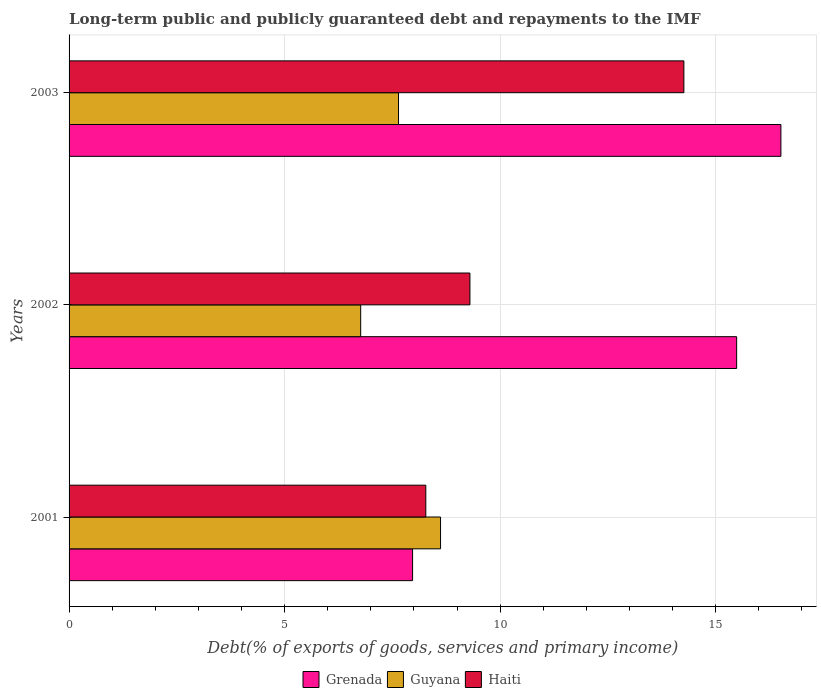How many bars are there on the 1st tick from the top?
Your answer should be compact. 3. How many bars are there on the 1st tick from the bottom?
Give a very brief answer. 3. In how many cases, is the number of bars for a given year not equal to the number of legend labels?
Provide a short and direct response. 0. What is the debt and repayments in Haiti in 2001?
Offer a very short reply. 8.28. Across all years, what is the maximum debt and repayments in Grenada?
Your answer should be very brief. 16.51. Across all years, what is the minimum debt and repayments in Guyana?
Give a very brief answer. 6.76. In which year was the debt and repayments in Grenada maximum?
Make the answer very short. 2003. In which year was the debt and repayments in Grenada minimum?
Offer a terse response. 2001. What is the total debt and repayments in Guyana in the graph?
Keep it short and to the point. 23.02. What is the difference between the debt and repayments in Haiti in 2001 and that in 2002?
Provide a short and direct response. -1.02. What is the difference between the debt and repayments in Grenada in 2003 and the debt and repayments in Haiti in 2002?
Keep it short and to the point. 7.21. What is the average debt and repayments in Haiti per year?
Keep it short and to the point. 10.61. In the year 2002, what is the difference between the debt and repayments in Grenada and debt and repayments in Guyana?
Offer a very short reply. 8.72. In how many years, is the debt and repayments in Haiti greater than 5 %?
Keep it short and to the point. 3. What is the ratio of the debt and repayments in Haiti in 2001 to that in 2003?
Your answer should be very brief. 0.58. Is the difference between the debt and repayments in Grenada in 2002 and 2003 greater than the difference between the debt and repayments in Guyana in 2002 and 2003?
Ensure brevity in your answer.  No. What is the difference between the highest and the second highest debt and repayments in Guyana?
Your answer should be very brief. 0.98. What is the difference between the highest and the lowest debt and repayments in Haiti?
Keep it short and to the point. 5.99. What does the 2nd bar from the top in 2003 represents?
Your answer should be compact. Guyana. What does the 1st bar from the bottom in 2003 represents?
Keep it short and to the point. Grenada. Is it the case that in every year, the sum of the debt and repayments in Haiti and debt and repayments in Guyana is greater than the debt and repayments in Grenada?
Make the answer very short. Yes. How many bars are there?
Offer a terse response. 9. What is the difference between two consecutive major ticks on the X-axis?
Provide a short and direct response. 5. Are the values on the major ticks of X-axis written in scientific E-notation?
Make the answer very short. No. Does the graph contain any zero values?
Your answer should be very brief. No. How many legend labels are there?
Keep it short and to the point. 3. What is the title of the graph?
Keep it short and to the point. Long-term public and publicly guaranteed debt and repayments to the IMF. Does "Niger" appear as one of the legend labels in the graph?
Your answer should be very brief. No. What is the label or title of the X-axis?
Your answer should be compact. Debt(% of exports of goods, services and primary income). What is the label or title of the Y-axis?
Make the answer very short. Years. What is the Debt(% of exports of goods, services and primary income) in Grenada in 2001?
Keep it short and to the point. 7.97. What is the Debt(% of exports of goods, services and primary income) in Guyana in 2001?
Keep it short and to the point. 8.62. What is the Debt(% of exports of goods, services and primary income) of Haiti in 2001?
Offer a terse response. 8.28. What is the Debt(% of exports of goods, services and primary income) of Grenada in 2002?
Ensure brevity in your answer.  15.49. What is the Debt(% of exports of goods, services and primary income) of Guyana in 2002?
Ensure brevity in your answer.  6.76. What is the Debt(% of exports of goods, services and primary income) of Haiti in 2002?
Keep it short and to the point. 9.3. What is the Debt(% of exports of goods, services and primary income) of Grenada in 2003?
Your answer should be very brief. 16.51. What is the Debt(% of exports of goods, services and primary income) in Guyana in 2003?
Provide a short and direct response. 7.64. What is the Debt(% of exports of goods, services and primary income) in Haiti in 2003?
Your answer should be compact. 14.26. Across all years, what is the maximum Debt(% of exports of goods, services and primary income) in Grenada?
Provide a short and direct response. 16.51. Across all years, what is the maximum Debt(% of exports of goods, services and primary income) of Guyana?
Provide a succinct answer. 8.62. Across all years, what is the maximum Debt(% of exports of goods, services and primary income) in Haiti?
Your answer should be very brief. 14.26. Across all years, what is the minimum Debt(% of exports of goods, services and primary income) of Grenada?
Provide a short and direct response. 7.97. Across all years, what is the minimum Debt(% of exports of goods, services and primary income) of Guyana?
Provide a succinct answer. 6.76. Across all years, what is the minimum Debt(% of exports of goods, services and primary income) in Haiti?
Your response must be concise. 8.28. What is the total Debt(% of exports of goods, services and primary income) in Grenada in the graph?
Your response must be concise. 39.96. What is the total Debt(% of exports of goods, services and primary income) in Guyana in the graph?
Give a very brief answer. 23.02. What is the total Debt(% of exports of goods, services and primary income) of Haiti in the graph?
Your answer should be very brief. 31.83. What is the difference between the Debt(% of exports of goods, services and primary income) in Grenada in 2001 and that in 2002?
Provide a succinct answer. -7.52. What is the difference between the Debt(% of exports of goods, services and primary income) of Guyana in 2001 and that in 2002?
Offer a terse response. 1.85. What is the difference between the Debt(% of exports of goods, services and primary income) of Haiti in 2001 and that in 2002?
Keep it short and to the point. -1.02. What is the difference between the Debt(% of exports of goods, services and primary income) in Grenada in 2001 and that in 2003?
Offer a very short reply. -8.54. What is the difference between the Debt(% of exports of goods, services and primary income) of Guyana in 2001 and that in 2003?
Offer a terse response. 0.98. What is the difference between the Debt(% of exports of goods, services and primary income) of Haiti in 2001 and that in 2003?
Your answer should be compact. -5.99. What is the difference between the Debt(% of exports of goods, services and primary income) in Grenada in 2002 and that in 2003?
Keep it short and to the point. -1.03. What is the difference between the Debt(% of exports of goods, services and primary income) of Guyana in 2002 and that in 2003?
Give a very brief answer. -0.88. What is the difference between the Debt(% of exports of goods, services and primary income) in Haiti in 2002 and that in 2003?
Give a very brief answer. -4.96. What is the difference between the Debt(% of exports of goods, services and primary income) of Grenada in 2001 and the Debt(% of exports of goods, services and primary income) of Guyana in 2002?
Keep it short and to the point. 1.2. What is the difference between the Debt(% of exports of goods, services and primary income) in Grenada in 2001 and the Debt(% of exports of goods, services and primary income) in Haiti in 2002?
Your answer should be very brief. -1.33. What is the difference between the Debt(% of exports of goods, services and primary income) of Guyana in 2001 and the Debt(% of exports of goods, services and primary income) of Haiti in 2002?
Keep it short and to the point. -0.68. What is the difference between the Debt(% of exports of goods, services and primary income) of Grenada in 2001 and the Debt(% of exports of goods, services and primary income) of Guyana in 2003?
Provide a short and direct response. 0.33. What is the difference between the Debt(% of exports of goods, services and primary income) in Grenada in 2001 and the Debt(% of exports of goods, services and primary income) in Haiti in 2003?
Offer a very short reply. -6.29. What is the difference between the Debt(% of exports of goods, services and primary income) of Guyana in 2001 and the Debt(% of exports of goods, services and primary income) of Haiti in 2003?
Provide a succinct answer. -5.64. What is the difference between the Debt(% of exports of goods, services and primary income) in Grenada in 2002 and the Debt(% of exports of goods, services and primary income) in Guyana in 2003?
Provide a short and direct response. 7.84. What is the difference between the Debt(% of exports of goods, services and primary income) of Grenada in 2002 and the Debt(% of exports of goods, services and primary income) of Haiti in 2003?
Make the answer very short. 1.22. What is the difference between the Debt(% of exports of goods, services and primary income) in Guyana in 2002 and the Debt(% of exports of goods, services and primary income) in Haiti in 2003?
Keep it short and to the point. -7.5. What is the average Debt(% of exports of goods, services and primary income) of Grenada per year?
Offer a terse response. 13.32. What is the average Debt(% of exports of goods, services and primary income) of Guyana per year?
Make the answer very short. 7.67. What is the average Debt(% of exports of goods, services and primary income) in Haiti per year?
Your answer should be very brief. 10.61. In the year 2001, what is the difference between the Debt(% of exports of goods, services and primary income) of Grenada and Debt(% of exports of goods, services and primary income) of Guyana?
Give a very brief answer. -0.65. In the year 2001, what is the difference between the Debt(% of exports of goods, services and primary income) in Grenada and Debt(% of exports of goods, services and primary income) in Haiti?
Give a very brief answer. -0.31. In the year 2001, what is the difference between the Debt(% of exports of goods, services and primary income) in Guyana and Debt(% of exports of goods, services and primary income) in Haiti?
Keep it short and to the point. 0.34. In the year 2002, what is the difference between the Debt(% of exports of goods, services and primary income) of Grenada and Debt(% of exports of goods, services and primary income) of Guyana?
Your answer should be compact. 8.72. In the year 2002, what is the difference between the Debt(% of exports of goods, services and primary income) of Grenada and Debt(% of exports of goods, services and primary income) of Haiti?
Provide a short and direct response. 6.19. In the year 2002, what is the difference between the Debt(% of exports of goods, services and primary income) of Guyana and Debt(% of exports of goods, services and primary income) of Haiti?
Give a very brief answer. -2.53. In the year 2003, what is the difference between the Debt(% of exports of goods, services and primary income) of Grenada and Debt(% of exports of goods, services and primary income) of Guyana?
Ensure brevity in your answer.  8.87. In the year 2003, what is the difference between the Debt(% of exports of goods, services and primary income) of Grenada and Debt(% of exports of goods, services and primary income) of Haiti?
Provide a succinct answer. 2.25. In the year 2003, what is the difference between the Debt(% of exports of goods, services and primary income) of Guyana and Debt(% of exports of goods, services and primary income) of Haiti?
Offer a very short reply. -6.62. What is the ratio of the Debt(% of exports of goods, services and primary income) of Grenada in 2001 to that in 2002?
Provide a short and direct response. 0.51. What is the ratio of the Debt(% of exports of goods, services and primary income) in Guyana in 2001 to that in 2002?
Offer a very short reply. 1.27. What is the ratio of the Debt(% of exports of goods, services and primary income) in Haiti in 2001 to that in 2002?
Your response must be concise. 0.89. What is the ratio of the Debt(% of exports of goods, services and primary income) of Grenada in 2001 to that in 2003?
Provide a short and direct response. 0.48. What is the ratio of the Debt(% of exports of goods, services and primary income) of Guyana in 2001 to that in 2003?
Keep it short and to the point. 1.13. What is the ratio of the Debt(% of exports of goods, services and primary income) of Haiti in 2001 to that in 2003?
Keep it short and to the point. 0.58. What is the ratio of the Debt(% of exports of goods, services and primary income) of Grenada in 2002 to that in 2003?
Make the answer very short. 0.94. What is the ratio of the Debt(% of exports of goods, services and primary income) in Guyana in 2002 to that in 2003?
Your answer should be very brief. 0.89. What is the ratio of the Debt(% of exports of goods, services and primary income) of Haiti in 2002 to that in 2003?
Keep it short and to the point. 0.65. What is the difference between the highest and the second highest Debt(% of exports of goods, services and primary income) in Grenada?
Your answer should be very brief. 1.03. What is the difference between the highest and the second highest Debt(% of exports of goods, services and primary income) of Guyana?
Your response must be concise. 0.98. What is the difference between the highest and the second highest Debt(% of exports of goods, services and primary income) in Haiti?
Your response must be concise. 4.96. What is the difference between the highest and the lowest Debt(% of exports of goods, services and primary income) of Grenada?
Make the answer very short. 8.54. What is the difference between the highest and the lowest Debt(% of exports of goods, services and primary income) of Guyana?
Your response must be concise. 1.85. What is the difference between the highest and the lowest Debt(% of exports of goods, services and primary income) of Haiti?
Offer a very short reply. 5.99. 